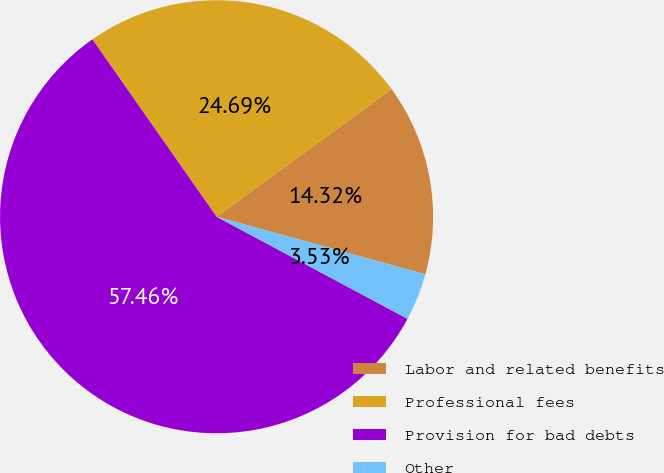<chart> <loc_0><loc_0><loc_500><loc_500><pie_chart><fcel>Labor and related benefits<fcel>Professional fees<fcel>Provision for bad debts<fcel>Other<nl><fcel>14.32%<fcel>24.69%<fcel>57.47%<fcel>3.53%<nl></chart> 